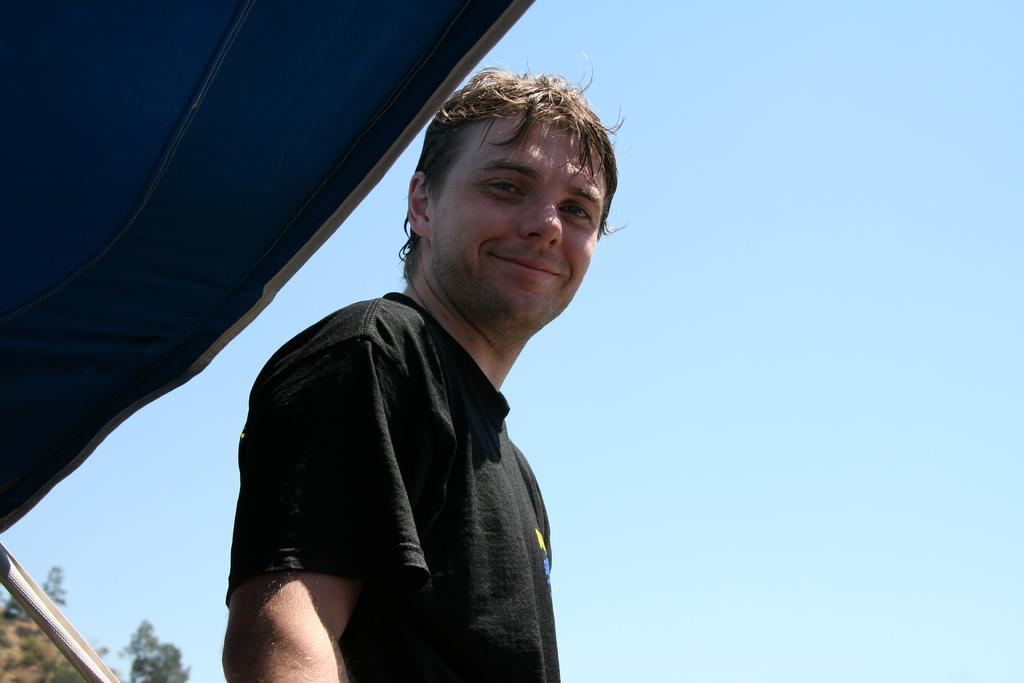What is the man in the image wearing? The man in the image is wearing a black t-shirt. What can be seen behind the man in the image? The sky is visible behind the man in the image. What objects are on the left side of the image? There are two objects on the left side of the image. What type of natural vegetation is present in the image? Trees are present in the image. What is the man's throat doing in the image? There is no indication of the man's throat in the image, as it only shows him wearing a black t-shirt. 